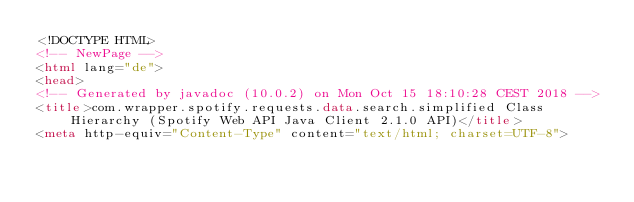Convert code to text. <code><loc_0><loc_0><loc_500><loc_500><_HTML_><!DOCTYPE HTML>
<!-- NewPage -->
<html lang="de">
<head>
<!-- Generated by javadoc (10.0.2) on Mon Oct 15 18:10:28 CEST 2018 -->
<title>com.wrapper.spotify.requests.data.search.simplified Class Hierarchy (Spotify Web API Java Client 2.1.0 API)</title>
<meta http-equiv="Content-Type" content="text/html; charset=UTF-8"></code> 